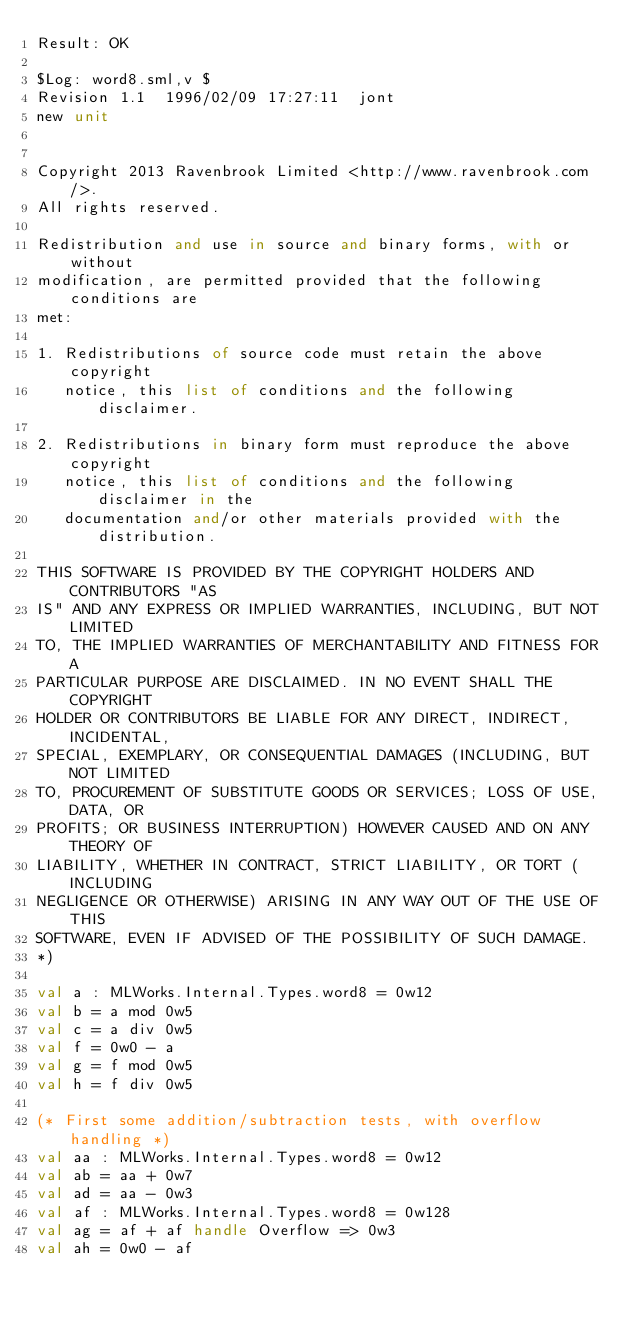Convert code to text. <code><loc_0><loc_0><loc_500><loc_500><_SML_>Result: OK
 
$Log: word8.sml,v $
Revision 1.1  1996/02/09 17:27:11  jont
new unit


Copyright 2013 Ravenbrook Limited <http://www.ravenbrook.com/>.
All rights reserved.

Redistribution and use in source and binary forms, with or without
modification, are permitted provided that the following conditions are
met:

1. Redistributions of source code must retain the above copyright
   notice, this list of conditions and the following disclaimer.

2. Redistributions in binary form must reproduce the above copyright
   notice, this list of conditions and the following disclaimer in the
   documentation and/or other materials provided with the distribution.

THIS SOFTWARE IS PROVIDED BY THE COPYRIGHT HOLDERS AND CONTRIBUTORS "AS
IS" AND ANY EXPRESS OR IMPLIED WARRANTIES, INCLUDING, BUT NOT LIMITED
TO, THE IMPLIED WARRANTIES OF MERCHANTABILITY AND FITNESS FOR A
PARTICULAR PURPOSE ARE DISCLAIMED. IN NO EVENT SHALL THE COPYRIGHT
HOLDER OR CONTRIBUTORS BE LIABLE FOR ANY DIRECT, INDIRECT, INCIDENTAL,
SPECIAL, EXEMPLARY, OR CONSEQUENTIAL DAMAGES (INCLUDING, BUT NOT LIMITED
TO, PROCUREMENT OF SUBSTITUTE GOODS OR SERVICES; LOSS OF USE, DATA, OR
PROFITS; OR BUSINESS INTERRUPTION) HOWEVER CAUSED AND ON ANY THEORY OF
LIABILITY, WHETHER IN CONTRACT, STRICT LIABILITY, OR TORT (INCLUDING
NEGLIGENCE OR OTHERWISE) ARISING IN ANY WAY OUT OF THE USE OF THIS
SOFTWARE, EVEN IF ADVISED OF THE POSSIBILITY OF SUCH DAMAGE.
*)

val a : MLWorks.Internal.Types.word8 = 0w12
val b = a mod 0w5
val c = a div 0w5
val f = 0w0 - a
val g = f mod 0w5
val h = f div 0w5

(* First some addition/subtraction tests, with overflow handling *)
val aa : MLWorks.Internal.Types.word8 = 0w12
val ab = aa + 0w7
val ad = aa - 0w3
val af : MLWorks.Internal.Types.word8 = 0w128
val ag = af + af handle Overflow => 0w3
val ah = 0w0 - af</code> 